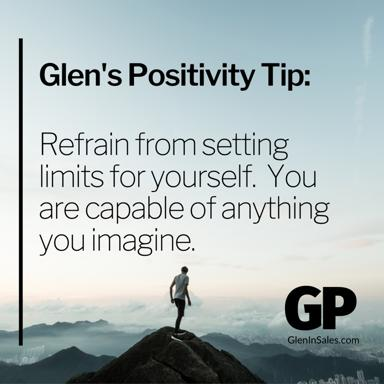What message does the image of a man standing on top of a mountain convey in relation to Glen's Positivity Tip? The image of a man at the summit of a mountain vividly encapsulates the essence of Glen's Positivity Tip. It symbolizes the pinnacle of personal achievement and the overcoming of mental and physical challenges. The visual suggests that by embracing a mindset unbounded by limitations, similar to how a climber conquers a mountain, one can achieve extraordinary feats. This portrayal reinforces the power of maintaining a positive and limitless perspective in life's pursuits. 